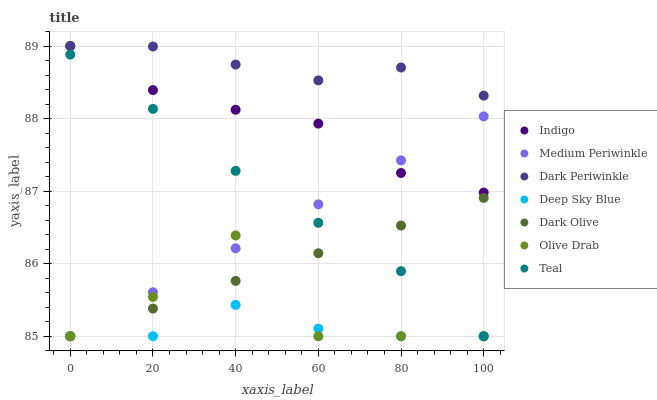Does Deep Sky Blue have the minimum area under the curve?
Answer yes or no. Yes. Does Dark Periwinkle have the maximum area under the curve?
Answer yes or no. Yes. Does Teal have the minimum area under the curve?
Answer yes or no. No. Does Teal have the maximum area under the curve?
Answer yes or no. No. Is Dark Olive the smoothest?
Answer yes or no. Yes. Is Olive Drab the roughest?
Answer yes or no. Yes. Is Teal the smoothest?
Answer yes or no. No. Is Teal the roughest?
Answer yes or no. No. Does Teal have the lowest value?
Answer yes or no. Yes. Does Dark Periwinkle have the lowest value?
Answer yes or no. No. Does Dark Periwinkle have the highest value?
Answer yes or no. Yes. Does Teal have the highest value?
Answer yes or no. No. Is Olive Drab less than Dark Periwinkle?
Answer yes or no. Yes. Is Indigo greater than Deep Sky Blue?
Answer yes or no. Yes. Does Medium Periwinkle intersect Deep Sky Blue?
Answer yes or no. Yes. Is Medium Periwinkle less than Deep Sky Blue?
Answer yes or no. No. Is Medium Periwinkle greater than Deep Sky Blue?
Answer yes or no. No. Does Olive Drab intersect Dark Periwinkle?
Answer yes or no. No. 